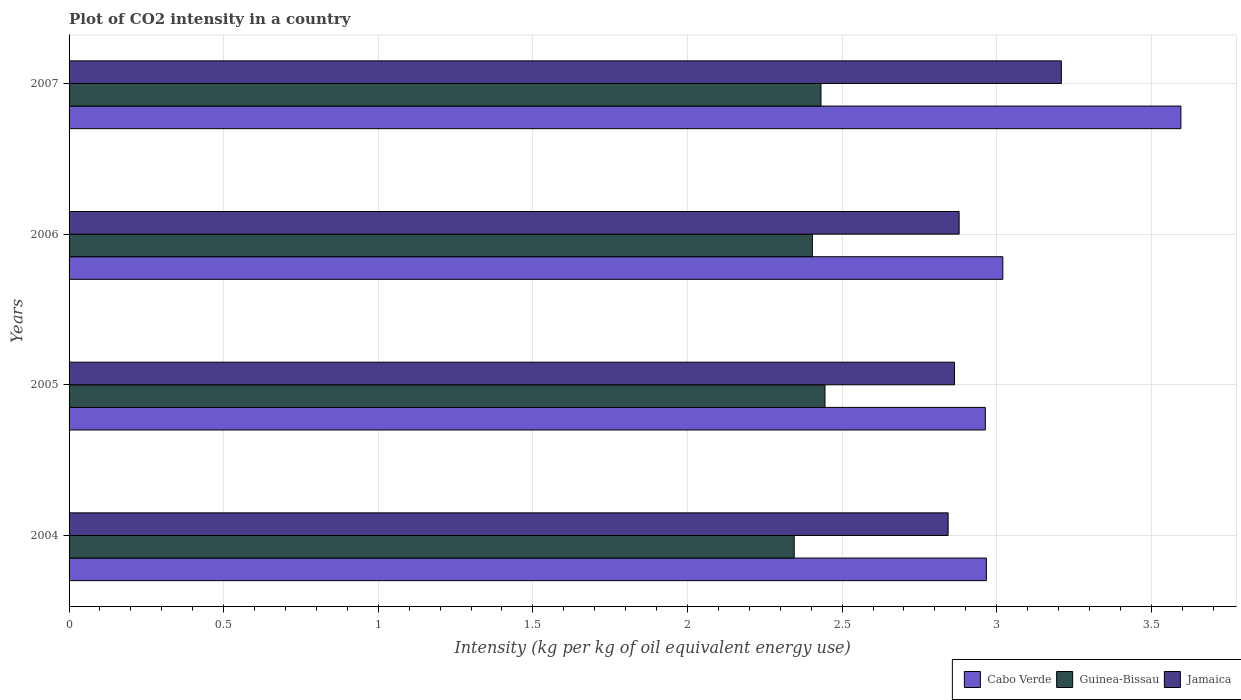How many different coloured bars are there?
Offer a terse response. 3. How many groups of bars are there?
Your response must be concise. 4. Are the number of bars per tick equal to the number of legend labels?
Make the answer very short. Yes. Are the number of bars on each tick of the Y-axis equal?
Your answer should be compact. Yes. How many bars are there on the 4th tick from the top?
Offer a terse response. 3. What is the label of the 3rd group of bars from the top?
Offer a terse response. 2005. In how many cases, is the number of bars for a given year not equal to the number of legend labels?
Keep it short and to the point. 0. What is the CO2 intensity in in Guinea-Bissau in 2005?
Your response must be concise. 2.44. Across all years, what is the maximum CO2 intensity in in Guinea-Bissau?
Keep it short and to the point. 2.44. Across all years, what is the minimum CO2 intensity in in Guinea-Bissau?
Your answer should be compact. 2.35. In which year was the CO2 intensity in in Guinea-Bissau minimum?
Your answer should be compact. 2004. What is the total CO2 intensity in in Jamaica in the graph?
Ensure brevity in your answer.  11.79. What is the difference between the CO2 intensity in in Cabo Verde in 2005 and that in 2006?
Give a very brief answer. -0.06. What is the difference between the CO2 intensity in in Jamaica in 2004 and the CO2 intensity in in Cabo Verde in 2005?
Your response must be concise. -0.12. What is the average CO2 intensity in in Guinea-Bissau per year?
Provide a succinct answer. 2.41. In the year 2007, what is the difference between the CO2 intensity in in Jamaica and CO2 intensity in in Cabo Verde?
Keep it short and to the point. -0.39. In how many years, is the CO2 intensity in in Guinea-Bissau greater than 1.7 kg?
Offer a terse response. 4. What is the ratio of the CO2 intensity in in Guinea-Bissau in 2004 to that in 2007?
Your answer should be compact. 0.96. Is the CO2 intensity in in Cabo Verde in 2005 less than that in 2006?
Ensure brevity in your answer.  Yes. Is the difference between the CO2 intensity in in Jamaica in 2005 and 2007 greater than the difference between the CO2 intensity in in Cabo Verde in 2005 and 2007?
Keep it short and to the point. Yes. What is the difference between the highest and the second highest CO2 intensity in in Jamaica?
Make the answer very short. 0.33. What is the difference between the highest and the lowest CO2 intensity in in Jamaica?
Keep it short and to the point. 0.37. Is the sum of the CO2 intensity in in Jamaica in 2005 and 2007 greater than the maximum CO2 intensity in in Guinea-Bissau across all years?
Your response must be concise. Yes. What does the 1st bar from the top in 2004 represents?
Your answer should be compact. Jamaica. What does the 1st bar from the bottom in 2006 represents?
Your answer should be compact. Cabo Verde. Is it the case that in every year, the sum of the CO2 intensity in in Jamaica and CO2 intensity in in Guinea-Bissau is greater than the CO2 intensity in in Cabo Verde?
Provide a succinct answer. Yes. How many years are there in the graph?
Provide a short and direct response. 4. What is the difference between two consecutive major ticks on the X-axis?
Your response must be concise. 0.5. Does the graph contain any zero values?
Give a very brief answer. No. Does the graph contain grids?
Ensure brevity in your answer.  Yes. How many legend labels are there?
Your response must be concise. 3. How are the legend labels stacked?
Offer a very short reply. Horizontal. What is the title of the graph?
Your response must be concise. Plot of CO2 intensity in a country. Does "High income: OECD" appear as one of the legend labels in the graph?
Offer a very short reply. No. What is the label or title of the X-axis?
Provide a succinct answer. Intensity (kg per kg of oil equivalent energy use). What is the label or title of the Y-axis?
Make the answer very short. Years. What is the Intensity (kg per kg of oil equivalent energy use) of Cabo Verde in 2004?
Keep it short and to the point. 2.97. What is the Intensity (kg per kg of oil equivalent energy use) of Guinea-Bissau in 2004?
Offer a very short reply. 2.35. What is the Intensity (kg per kg of oil equivalent energy use) of Jamaica in 2004?
Keep it short and to the point. 2.84. What is the Intensity (kg per kg of oil equivalent energy use) in Cabo Verde in 2005?
Give a very brief answer. 2.96. What is the Intensity (kg per kg of oil equivalent energy use) in Guinea-Bissau in 2005?
Your answer should be very brief. 2.44. What is the Intensity (kg per kg of oil equivalent energy use) of Jamaica in 2005?
Offer a very short reply. 2.86. What is the Intensity (kg per kg of oil equivalent energy use) in Cabo Verde in 2006?
Your answer should be very brief. 3.02. What is the Intensity (kg per kg of oil equivalent energy use) in Guinea-Bissau in 2006?
Give a very brief answer. 2.4. What is the Intensity (kg per kg of oil equivalent energy use) of Jamaica in 2006?
Your answer should be compact. 2.88. What is the Intensity (kg per kg of oil equivalent energy use) of Cabo Verde in 2007?
Provide a succinct answer. 3.6. What is the Intensity (kg per kg of oil equivalent energy use) of Guinea-Bissau in 2007?
Ensure brevity in your answer.  2.43. What is the Intensity (kg per kg of oil equivalent energy use) in Jamaica in 2007?
Ensure brevity in your answer.  3.21. Across all years, what is the maximum Intensity (kg per kg of oil equivalent energy use) of Cabo Verde?
Your response must be concise. 3.6. Across all years, what is the maximum Intensity (kg per kg of oil equivalent energy use) in Guinea-Bissau?
Your answer should be very brief. 2.44. Across all years, what is the maximum Intensity (kg per kg of oil equivalent energy use) of Jamaica?
Your response must be concise. 3.21. Across all years, what is the minimum Intensity (kg per kg of oil equivalent energy use) of Cabo Verde?
Your answer should be very brief. 2.96. Across all years, what is the minimum Intensity (kg per kg of oil equivalent energy use) in Guinea-Bissau?
Your answer should be very brief. 2.35. Across all years, what is the minimum Intensity (kg per kg of oil equivalent energy use) in Jamaica?
Your response must be concise. 2.84. What is the total Intensity (kg per kg of oil equivalent energy use) in Cabo Verde in the graph?
Make the answer very short. 12.55. What is the total Intensity (kg per kg of oil equivalent energy use) of Guinea-Bissau in the graph?
Your answer should be very brief. 9.63. What is the total Intensity (kg per kg of oil equivalent energy use) of Jamaica in the graph?
Your response must be concise. 11.79. What is the difference between the Intensity (kg per kg of oil equivalent energy use) in Cabo Verde in 2004 and that in 2005?
Provide a short and direct response. 0. What is the difference between the Intensity (kg per kg of oil equivalent energy use) of Guinea-Bissau in 2004 and that in 2005?
Your response must be concise. -0.1. What is the difference between the Intensity (kg per kg of oil equivalent energy use) of Jamaica in 2004 and that in 2005?
Offer a terse response. -0.02. What is the difference between the Intensity (kg per kg of oil equivalent energy use) of Cabo Verde in 2004 and that in 2006?
Your response must be concise. -0.05. What is the difference between the Intensity (kg per kg of oil equivalent energy use) of Guinea-Bissau in 2004 and that in 2006?
Keep it short and to the point. -0.06. What is the difference between the Intensity (kg per kg of oil equivalent energy use) of Jamaica in 2004 and that in 2006?
Your response must be concise. -0.04. What is the difference between the Intensity (kg per kg of oil equivalent energy use) of Cabo Verde in 2004 and that in 2007?
Ensure brevity in your answer.  -0.63. What is the difference between the Intensity (kg per kg of oil equivalent energy use) in Guinea-Bissau in 2004 and that in 2007?
Your answer should be very brief. -0.09. What is the difference between the Intensity (kg per kg of oil equivalent energy use) of Jamaica in 2004 and that in 2007?
Offer a terse response. -0.37. What is the difference between the Intensity (kg per kg of oil equivalent energy use) of Cabo Verde in 2005 and that in 2006?
Your answer should be very brief. -0.06. What is the difference between the Intensity (kg per kg of oil equivalent energy use) in Guinea-Bissau in 2005 and that in 2006?
Make the answer very short. 0.04. What is the difference between the Intensity (kg per kg of oil equivalent energy use) in Jamaica in 2005 and that in 2006?
Your answer should be very brief. -0.01. What is the difference between the Intensity (kg per kg of oil equivalent energy use) in Cabo Verde in 2005 and that in 2007?
Keep it short and to the point. -0.63. What is the difference between the Intensity (kg per kg of oil equivalent energy use) in Guinea-Bissau in 2005 and that in 2007?
Provide a short and direct response. 0.01. What is the difference between the Intensity (kg per kg of oil equivalent energy use) of Jamaica in 2005 and that in 2007?
Ensure brevity in your answer.  -0.35. What is the difference between the Intensity (kg per kg of oil equivalent energy use) in Cabo Verde in 2006 and that in 2007?
Make the answer very short. -0.58. What is the difference between the Intensity (kg per kg of oil equivalent energy use) in Guinea-Bissau in 2006 and that in 2007?
Offer a very short reply. -0.03. What is the difference between the Intensity (kg per kg of oil equivalent energy use) in Jamaica in 2006 and that in 2007?
Provide a succinct answer. -0.33. What is the difference between the Intensity (kg per kg of oil equivalent energy use) of Cabo Verde in 2004 and the Intensity (kg per kg of oil equivalent energy use) of Guinea-Bissau in 2005?
Ensure brevity in your answer.  0.52. What is the difference between the Intensity (kg per kg of oil equivalent energy use) in Cabo Verde in 2004 and the Intensity (kg per kg of oil equivalent energy use) in Jamaica in 2005?
Ensure brevity in your answer.  0.1. What is the difference between the Intensity (kg per kg of oil equivalent energy use) in Guinea-Bissau in 2004 and the Intensity (kg per kg of oil equivalent energy use) in Jamaica in 2005?
Give a very brief answer. -0.52. What is the difference between the Intensity (kg per kg of oil equivalent energy use) in Cabo Verde in 2004 and the Intensity (kg per kg of oil equivalent energy use) in Guinea-Bissau in 2006?
Keep it short and to the point. 0.56. What is the difference between the Intensity (kg per kg of oil equivalent energy use) in Cabo Verde in 2004 and the Intensity (kg per kg of oil equivalent energy use) in Jamaica in 2006?
Your answer should be very brief. 0.09. What is the difference between the Intensity (kg per kg of oil equivalent energy use) of Guinea-Bissau in 2004 and the Intensity (kg per kg of oil equivalent energy use) of Jamaica in 2006?
Your response must be concise. -0.53. What is the difference between the Intensity (kg per kg of oil equivalent energy use) of Cabo Verde in 2004 and the Intensity (kg per kg of oil equivalent energy use) of Guinea-Bissau in 2007?
Offer a very short reply. 0.53. What is the difference between the Intensity (kg per kg of oil equivalent energy use) in Cabo Verde in 2004 and the Intensity (kg per kg of oil equivalent energy use) in Jamaica in 2007?
Offer a terse response. -0.24. What is the difference between the Intensity (kg per kg of oil equivalent energy use) in Guinea-Bissau in 2004 and the Intensity (kg per kg of oil equivalent energy use) in Jamaica in 2007?
Your answer should be compact. -0.86. What is the difference between the Intensity (kg per kg of oil equivalent energy use) of Cabo Verde in 2005 and the Intensity (kg per kg of oil equivalent energy use) of Guinea-Bissau in 2006?
Ensure brevity in your answer.  0.56. What is the difference between the Intensity (kg per kg of oil equivalent energy use) in Cabo Verde in 2005 and the Intensity (kg per kg of oil equivalent energy use) in Jamaica in 2006?
Ensure brevity in your answer.  0.08. What is the difference between the Intensity (kg per kg of oil equivalent energy use) of Guinea-Bissau in 2005 and the Intensity (kg per kg of oil equivalent energy use) of Jamaica in 2006?
Make the answer very short. -0.43. What is the difference between the Intensity (kg per kg of oil equivalent energy use) in Cabo Verde in 2005 and the Intensity (kg per kg of oil equivalent energy use) in Guinea-Bissau in 2007?
Give a very brief answer. 0.53. What is the difference between the Intensity (kg per kg of oil equivalent energy use) in Cabo Verde in 2005 and the Intensity (kg per kg of oil equivalent energy use) in Jamaica in 2007?
Your answer should be very brief. -0.25. What is the difference between the Intensity (kg per kg of oil equivalent energy use) in Guinea-Bissau in 2005 and the Intensity (kg per kg of oil equivalent energy use) in Jamaica in 2007?
Offer a very short reply. -0.76. What is the difference between the Intensity (kg per kg of oil equivalent energy use) of Cabo Verde in 2006 and the Intensity (kg per kg of oil equivalent energy use) of Guinea-Bissau in 2007?
Make the answer very short. 0.59. What is the difference between the Intensity (kg per kg of oil equivalent energy use) in Cabo Verde in 2006 and the Intensity (kg per kg of oil equivalent energy use) in Jamaica in 2007?
Your answer should be very brief. -0.19. What is the difference between the Intensity (kg per kg of oil equivalent energy use) in Guinea-Bissau in 2006 and the Intensity (kg per kg of oil equivalent energy use) in Jamaica in 2007?
Your answer should be very brief. -0.81. What is the average Intensity (kg per kg of oil equivalent energy use) in Cabo Verde per year?
Make the answer very short. 3.14. What is the average Intensity (kg per kg of oil equivalent energy use) in Guinea-Bissau per year?
Make the answer very short. 2.41. What is the average Intensity (kg per kg of oil equivalent energy use) of Jamaica per year?
Provide a succinct answer. 2.95. In the year 2004, what is the difference between the Intensity (kg per kg of oil equivalent energy use) in Cabo Verde and Intensity (kg per kg of oil equivalent energy use) in Guinea-Bissau?
Make the answer very short. 0.62. In the year 2004, what is the difference between the Intensity (kg per kg of oil equivalent energy use) of Cabo Verde and Intensity (kg per kg of oil equivalent energy use) of Jamaica?
Your response must be concise. 0.12. In the year 2004, what is the difference between the Intensity (kg per kg of oil equivalent energy use) in Guinea-Bissau and Intensity (kg per kg of oil equivalent energy use) in Jamaica?
Make the answer very short. -0.5. In the year 2005, what is the difference between the Intensity (kg per kg of oil equivalent energy use) of Cabo Verde and Intensity (kg per kg of oil equivalent energy use) of Guinea-Bissau?
Make the answer very short. 0.52. In the year 2005, what is the difference between the Intensity (kg per kg of oil equivalent energy use) in Cabo Verde and Intensity (kg per kg of oil equivalent energy use) in Jamaica?
Keep it short and to the point. 0.1. In the year 2005, what is the difference between the Intensity (kg per kg of oil equivalent energy use) in Guinea-Bissau and Intensity (kg per kg of oil equivalent energy use) in Jamaica?
Ensure brevity in your answer.  -0.42. In the year 2006, what is the difference between the Intensity (kg per kg of oil equivalent energy use) in Cabo Verde and Intensity (kg per kg of oil equivalent energy use) in Guinea-Bissau?
Ensure brevity in your answer.  0.62. In the year 2006, what is the difference between the Intensity (kg per kg of oil equivalent energy use) of Cabo Verde and Intensity (kg per kg of oil equivalent energy use) of Jamaica?
Your answer should be compact. 0.14. In the year 2006, what is the difference between the Intensity (kg per kg of oil equivalent energy use) of Guinea-Bissau and Intensity (kg per kg of oil equivalent energy use) of Jamaica?
Your answer should be very brief. -0.47. In the year 2007, what is the difference between the Intensity (kg per kg of oil equivalent energy use) in Cabo Verde and Intensity (kg per kg of oil equivalent energy use) in Guinea-Bissau?
Give a very brief answer. 1.16. In the year 2007, what is the difference between the Intensity (kg per kg of oil equivalent energy use) of Cabo Verde and Intensity (kg per kg of oil equivalent energy use) of Jamaica?
Give a very brief answer. 0.39. In the year 2007, what is the difference between the Intensity (kg per kg of oil equivalent energy use) of Guinea-Bissau and Intensity (kg per kg of oil equivalent energy use) of Jamaica?
Offer a terse response. -0.78. What is the ratio of the Intensity (kg per kg of oil equivalent energy use) in Cabo Verde in 2004 to that in 2005?
Ensure brevity in your answer.  1. What is the ratio of the Intensity (kg per kg of oil equivalent energy use) in Guinea-Bissau in 2004 to that in 2005?
Give a very brief answer. 0.96. What is the ratio of the Intensity (kg per kg of oil equivalent energy use) of Jamaica in 2004 to that in 2005?
Provide a short and direct response. 0.99. What is the ratio of the Intensity (kg per kg of oil equivalent energy use) of Cabo Verde in 2004 to that in 2006?
Offer a terse response. 0.98. What is the ratio of the Intensity (kg per kg of oil equivalent energy use) in Guinea-Bissau in 2004 to that in 2006?
Provide a succinct answer. 0.98. What is the ratio of the Intensity (kg per kg of oil equivalent energy use) in Jamaica in 2004 to that in 2006?
Provide a short and direct response. 0.99. What is the ratio of the Intensity (kg per kg of oil equivalent energy use) in Cabo Verde in 2004 to that in 2007?
Your answer should be compact. 0.82. What is the ratio of the Intensity (kg per kg of oil equivalent energy use) in Guinea-Bissau in 2004 to that in 2007?
Make the answer very short. 0.96. What is the ratio of the Intensity (kg per kg of oil equivalent energy use) of Jamaica in 2004 to that in 2007?
Provide a short and direct response. 0.89. What is the ratio of the Intensity (kg per kg of oil equivalent energy use) in Cabo Verde in 2005 to that in 2006?
Your response must be concise. 0.98. What is the ratio of the Intensity (kg per kg of oil equivalent energy use) in Guinea-Bissau in 2005 to that in 2006?
Your response must be concise. 1.02. What is the ratio of the Intensity (kg per kg of oil equivalent energy use) in Cabo Verde in 2005 to that in 2007?
Your answer should be very brief. 0.82. What is the ratio of the Intensity (kg per kg of oil equivalent energy use) in Jamaica in 2005 to that in 2007?
Your response must be concise. 0.89. What is the ratio of the Intensity (kg per kg of oil equivalent energy use) of Cabo Verde in 2006 to that in 2007?
Provide a succinct answer. 0.84. What is the ratio of the Intensity (kg per kg of oil equivalent energy use) of Guinea-Bissau in 2006 to that in 2007?
Your response must be concise. 0.99. What is the ratio of the Intensity (kg per kg of oil equivalent energy use) of Jamaica in 2006 to that in 2007?
Your answer should be very brief. 0.9. What is the difference between the highest and the second highest Intensity (kg per kg of oil equivalent energy use) of Cabo Verde?
Offer a very short reply. 0.58. What is the difference between the highest and the second highest Intensity (kg per kg of oil equivalent energy use) of Guinea-Bissau?
Offer a terse response. 0.01. What is the difference between the highest and the second highest Intensity (kg per kg of oil equivalent energy use) in Jamaica?
Keep it short and to the point. 0.33. What is the difference between the highest and the lowest Intensity (kg per kg of oil equivalent energy use) of Cabo Verde?
Offer a very short reply. 0.63. What is the difference between the highest and the lowest Intensity (kg per kg of oil equivalent energy use) in Guinea-Bissau?
Your answer should be very brief. 0.1. What is the difference between the highest and the lowest Intensity (kg per kg of oil equivalent energy use) in Jamaica?
Your answer should be very brief. 0.37. 